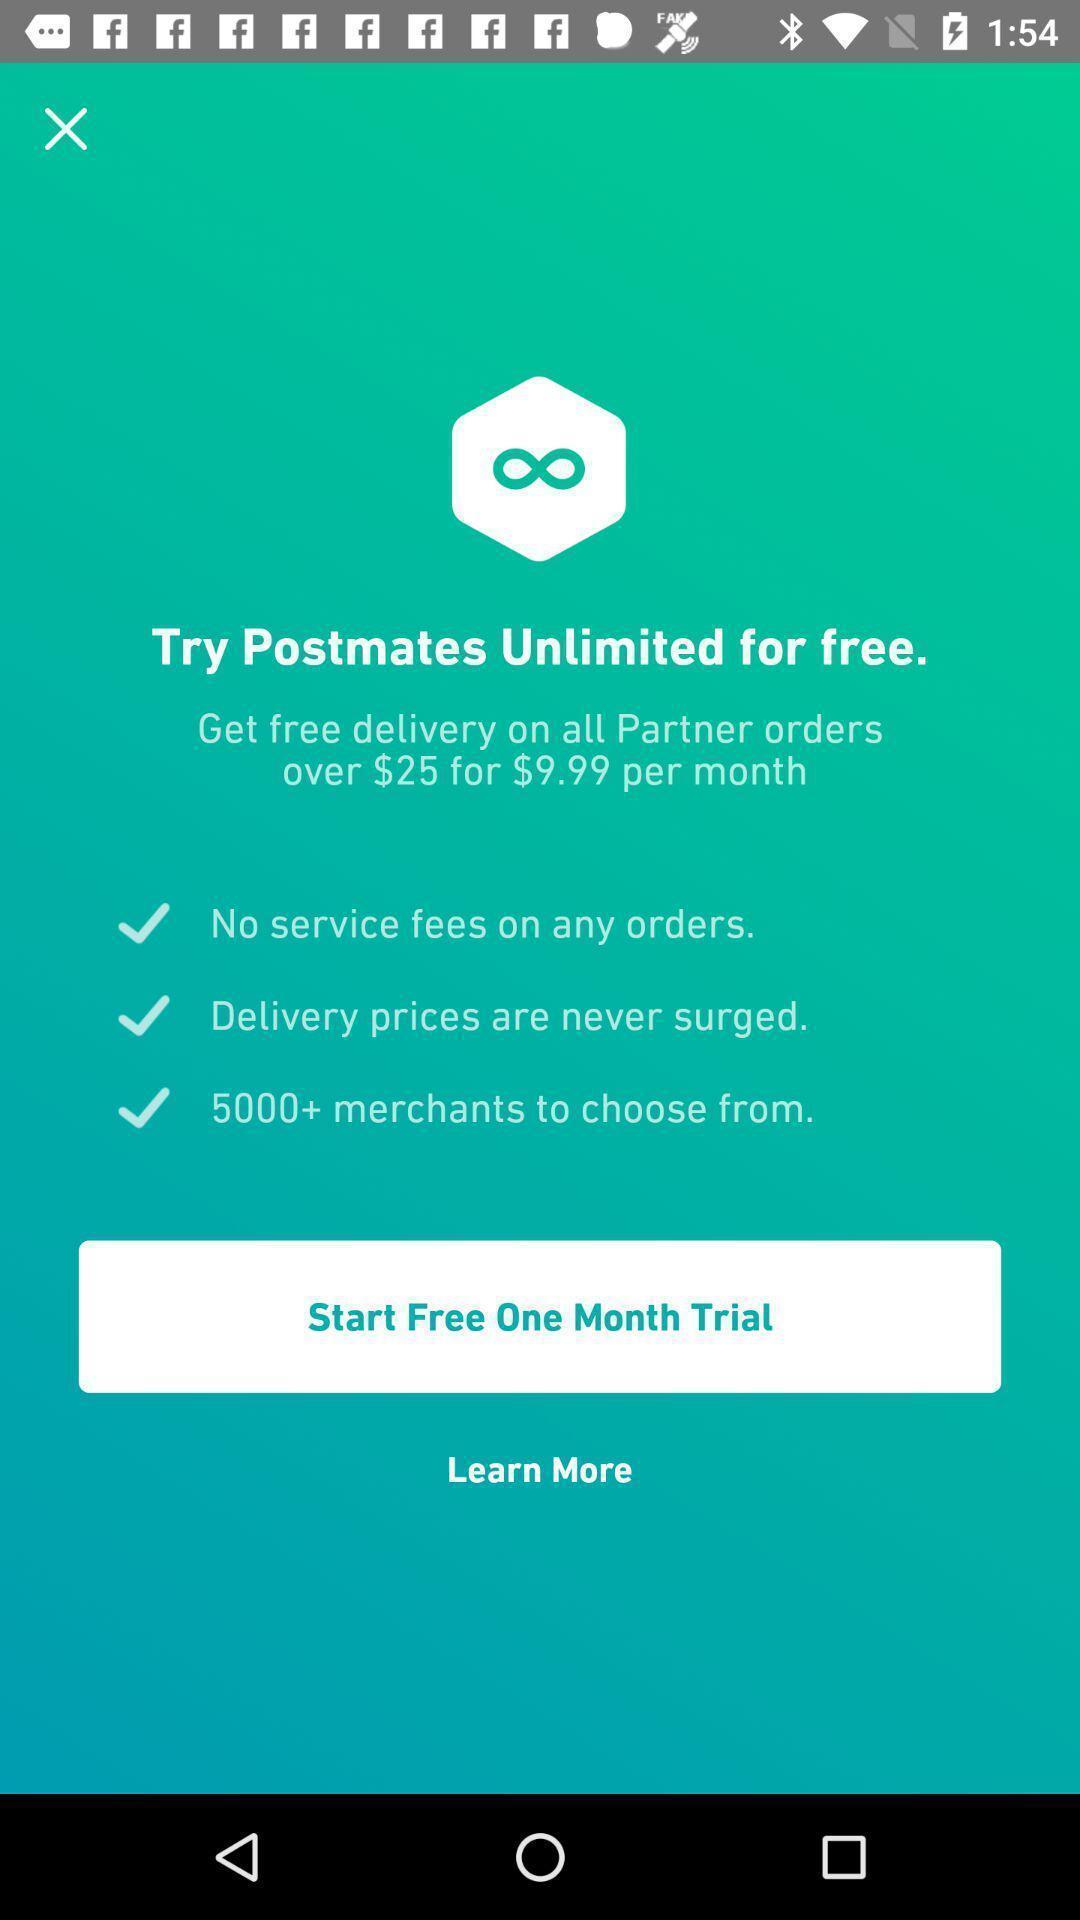Give me a narrative description of this picture. Welcome page of a food delivery app. 